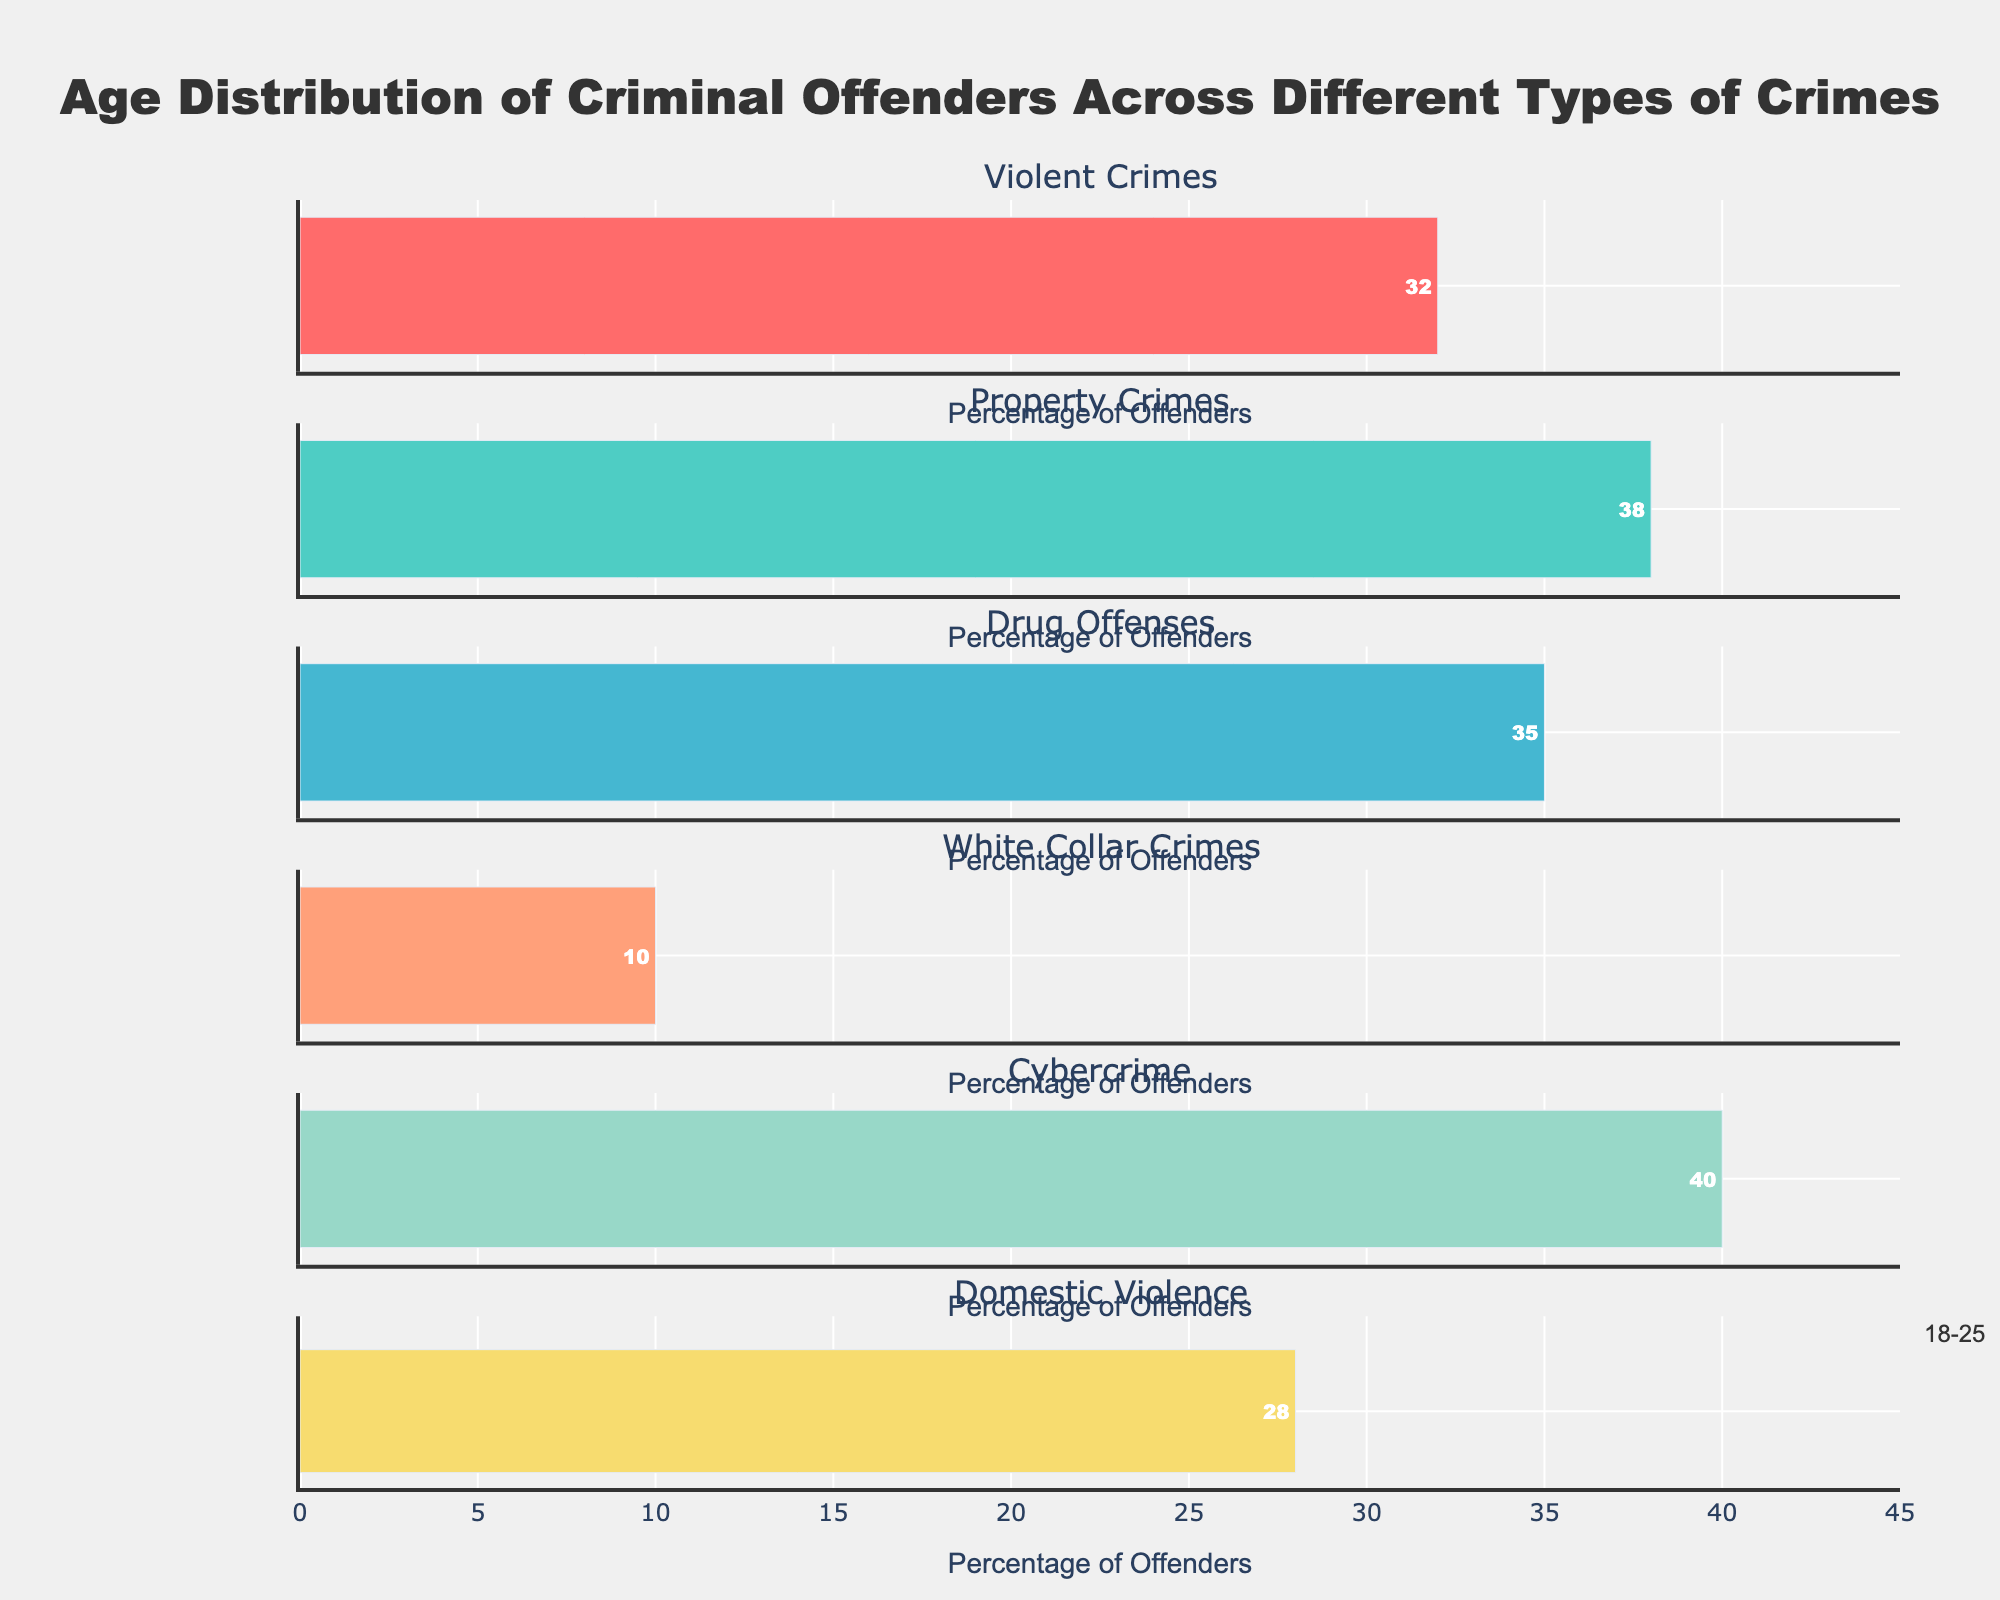What is the most common age group for offenders in violent crimes? The bar for the 18-25 age group is the longest in the sub-plot for violent crimes. This indicates that the 18-25 age group has the highest number of offenders for violent crimes.
Answer: 18-25 Which crime type has the highest number of offenders aged 46-55? By comparing the lengths of the bars for the 46-55 age group across all subplots, we see that white collar crimes have the longest bar in this age group, indicating the highest number of offenders.
Answer: White Collar Crimes How does the age distribution of offenders in cybercrime compare to other crime types? In the cybercrime subplot, the 18-25 and 26-35 age groups have the longest bars, indicating high numbers of young offenders. Other crime types, like white collar crimes, show a more balanced distribution or a peak in older age groups.
Answer: Younger age groups dominate in cybercrime Which age group has the least number of offenders across all crime types? Observing all subplots, the 56+ age group consistently has the shortest bars across all crime types, indicating the least number of offenders.
Answer: 56+ What is the total number of offenders aged 18-25 across all crime types? Sum the values for the 18-25 age group across all crime types: 32 (Violent Crimes) + 38 (Property Crimes) + 35 (Drug Offenses) + 10 (White Collar Crimes) + 40 (Cybercrime) + 28 (Domestic Violence) = 183.
Answer: 183 Which crime type has the most balanced age distribution? By examining the lengths of bars across age groups within each subplot, the white collar crimes subplot has relatively even lengths, indicating a more balanced distribution across age groups.
Answer: White Collar Crimes What percentage of offenders in domestic violence are in the 26-35 age group compared to the total number of domestic violence offenders? The number of domestic violence offenders in the 26-35 age group is 32. Summing all offenders in domestic violence gives 28 + 32 + 24 + 12 + 4 = 100. The percentage is (32/100) * 100 = 32%.
Answer: 32% 